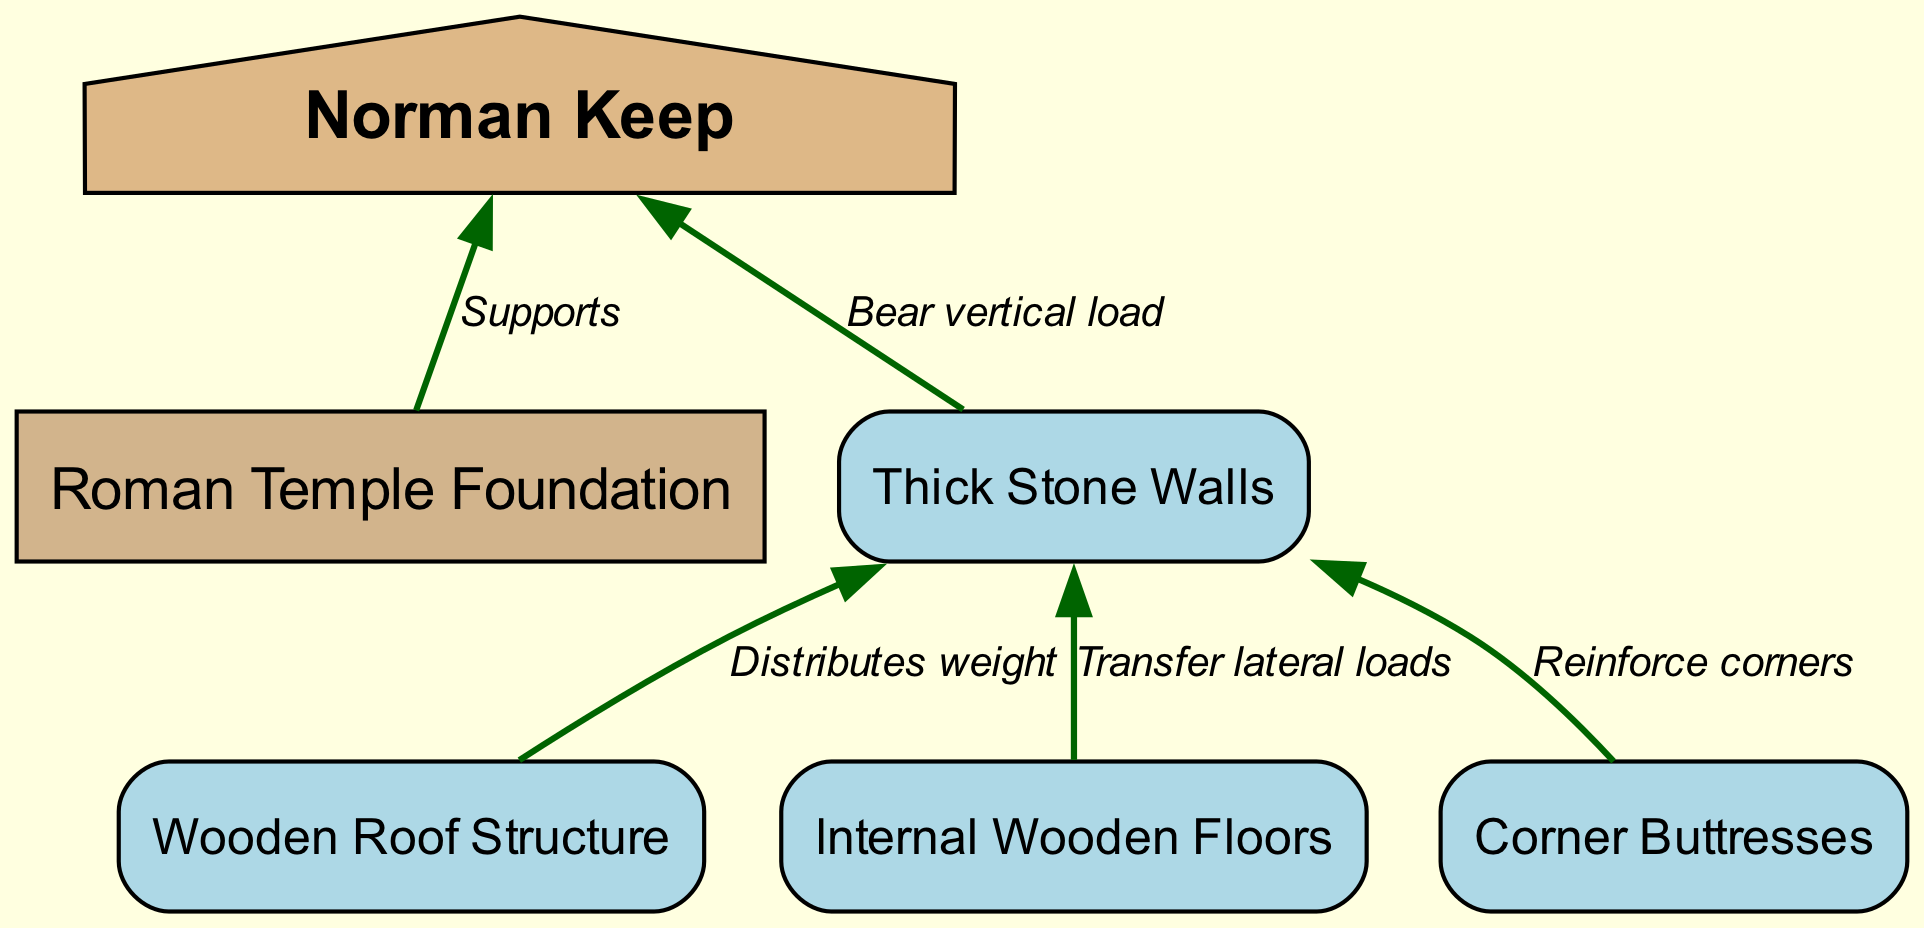What is the labeled structure at the top of the diagram? The diagram identifies the node at the top labeled "Norman Keep." This is the main structure depicted, emphasizing its significance.
Answer: Norman Keep How many nodes are there in total? The diagram contains six nodes representing different structural elements, including the Norman Keep, foundation, walls, roof, floors, and buttresses.
Answer: 6 What is the function of the foundation in relation to the keep? The foundation provides support for the Norman Keep, serving as a critical base that underpins the entire structure as represented in the directed edge labeled "Supports."
Answer: Supports Which element is responsible for distributing weight to the walls? The diagram indicates that the wooden roof structure is responsible for distributing weight to the thick stone walls, as shown in the edge connecting the roof to the walls labeled "Distributes weight."
Answer: Wooden Roof Structure What role do the corner buttresses play in this structural analysis? The corner buttresses are indicated to reinforce the corners of the walls by transferring additional support; this relationship is highlighted in the edge labeled "Reinforce corners."
Answer: Reinforce corners Which nodes are connected to the thick stone walls? The thick stone walls are connected to the roof for weight distribution, the floors for lateral load transfer, and the corner buttresses for added reinforcement, indicating mutual support among these elements.
Answer: Roof, Floors, Buttresses What transfers lateral loads to the walls? According to the diagram, the internal wooden floors are responsible for transferring lateral loads to the thick stone walls, which is depicted via the edge labeled "Transfer lateral loads."
Answer: Internal Wooden Floors Which element bears the vertical load? The thick stone walls bear the vertical load of the Norman Keep, as illustrated by the direct connection labeled "Bear vertical load" in the diagram.
Answer: Thick Stone Walls What is the relationship between the walls and the roof? The relationship is that the wooden roof structure distributes its weight onto the walls, which is denoted by the connecting edge labeled "Distributes weight." This implies a supportive function between these two elements.
Answer: Distributes weight 